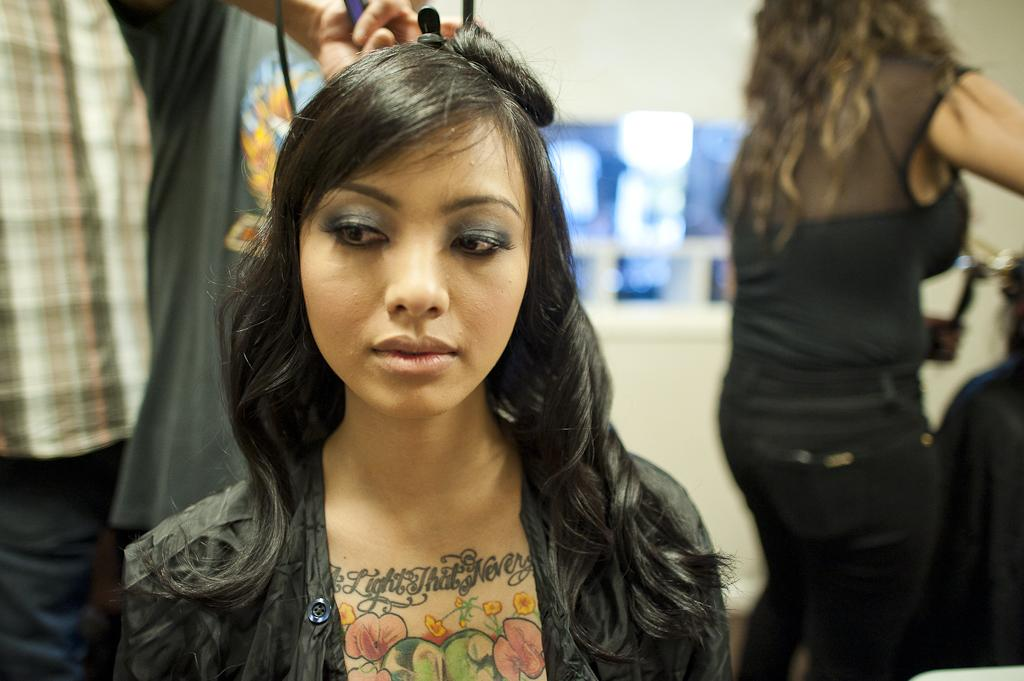How many people are in the image? There is a group of people in the image. What can be observed about the clothing of the people in the image? The people are wearing different colored dressers. Can you describe the action of one of the people in the image? One person is holding an object. What is the appearance of the background in the image? The background of the image is blurred. What type of cake is being shared among the bears in the image? There are no bears or cake present in the image. What is inside the box that one of the people is holding? The image does not provide information about the contents of the object being held by one of the people. 